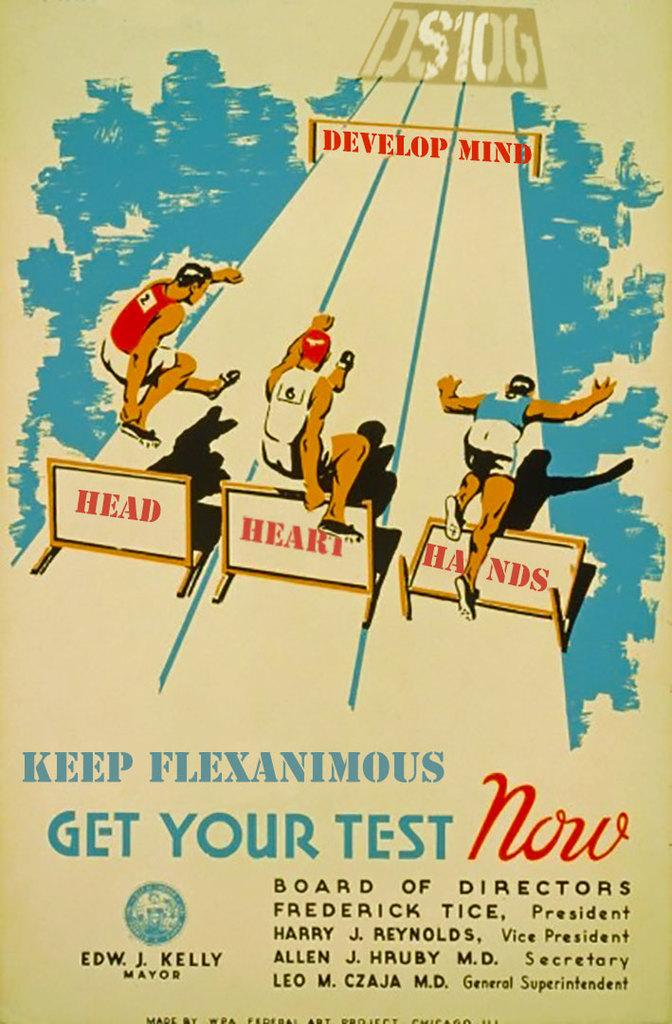<image>
Give a short and clear explanation of the subsequent image. A poster encouraging people to get their test now. 